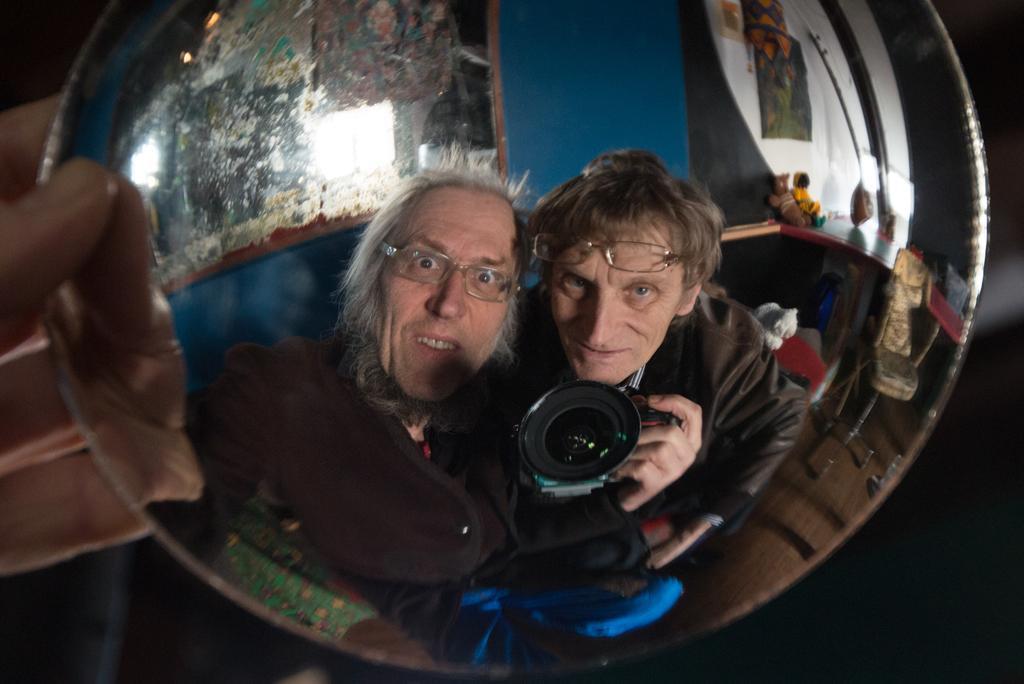Could you give a brief overview of what you see in this image? In this picture, we can see some reflections in the mirror like a two persons one of them is carrying a camera and we can see some objects on the ground. We can see the wall with mirrors and we can see some objects. 